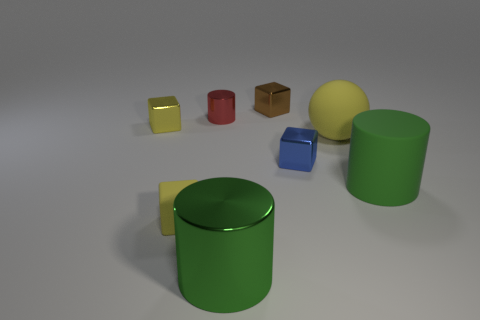There is a small yellow object that is the same material as the large yellow object; what is its shape?
Your answer should be very brief. Cube. Do the big green shiny object and the metal object that is behind the tiny shiny cylinder have the same shape?
Keep it short and to the point. No. The small yellow block that is in front of the tiny yellow cube behind the tiny blue object is made of what material?
Your response must be concise. Rubber. What number of other objects are there of the same shape as the blue thing?
Your answer should be compact. 3. There is a green metal object that is in front of the red thing; does it have the same shape as the yellow rubber object left of the large yellow ball?
Offer a very short reply. No. Is there any other thing that is the same material as the large yellow ball?
Give a very brief answer. Yes. What is the tiny blue block made of?
Provide a short and direct response. Metal. There is a yellow cube to the left of the rubber cube; what material is it?
Offer a very short reply. Metal. Are there any other things that are the same color as the matte cylinder?
Provide a short and direct response. Yes. What is the size of the brown object that is the same material as the tiny blue thing?
Provide a succinct answer. Small. 